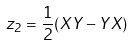<formula> <loc_0><loc_0><loc_500><loc_500>z _ { 2 } = \frac { 1 } { 2 } ( X Y - Y X )</formula> 